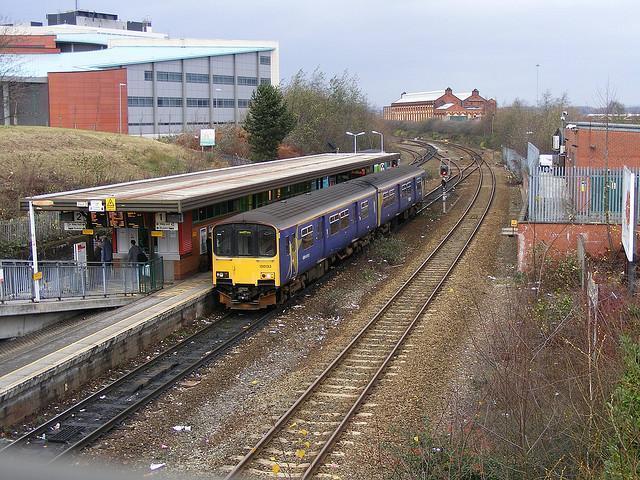At which building does the purple train stop?
Choose the correct response and explain in the format: 'Answer: answer
Rationale: rationale.'
Options: Depot, bus stop, airport, school. Answer: depot.
Rationale: A train is stopped at a small building along the tracks. places along train tracks for people to board have a place to buy tickets and wait for the train out of the weather. 